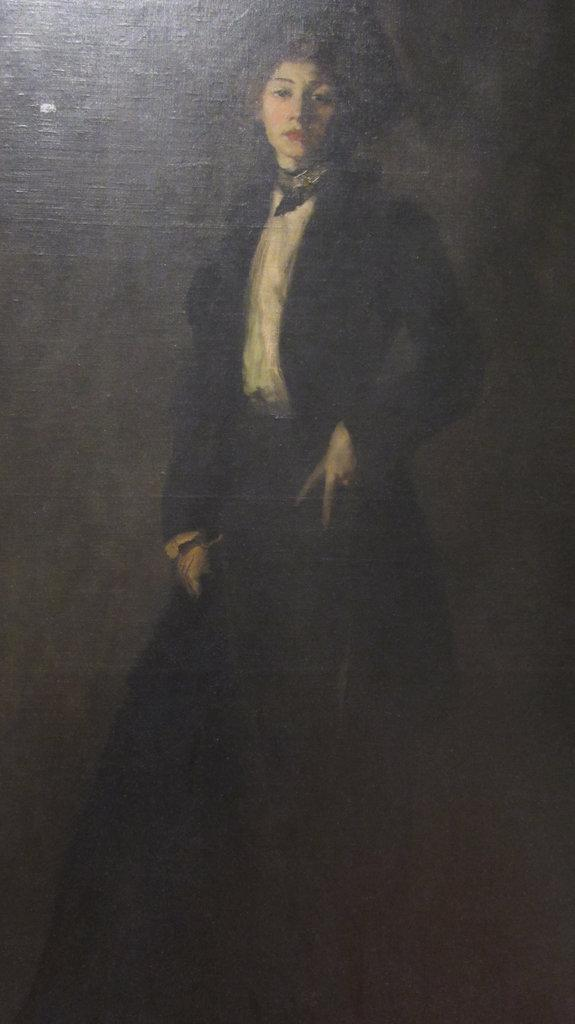What is the main subject of the image? The main subject of the image is a painting of a person. What can be observed about the person in the painting? The person in the painting is wearing a different costume. How many things can be seen on the person's feet in the image? There are no visible feet in the image, as it is a painting of a person wearing a costume. What color is the person's lip in the image? The image is a painting, and it does not depict the person's lips or any specific color for them. 